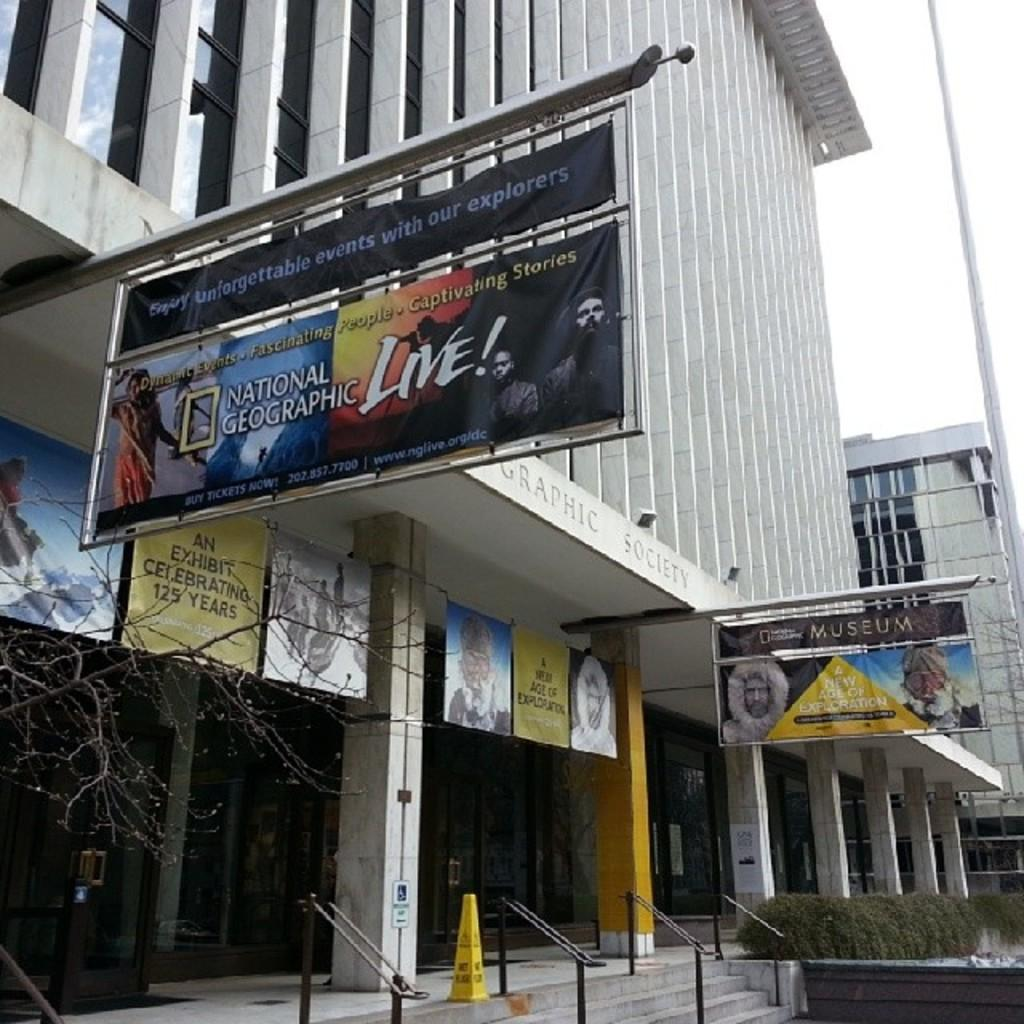<image>
Offer a succinct explanation of the picture presented. The poster asks the audience to enjoy unforgettable events with our explorers. 